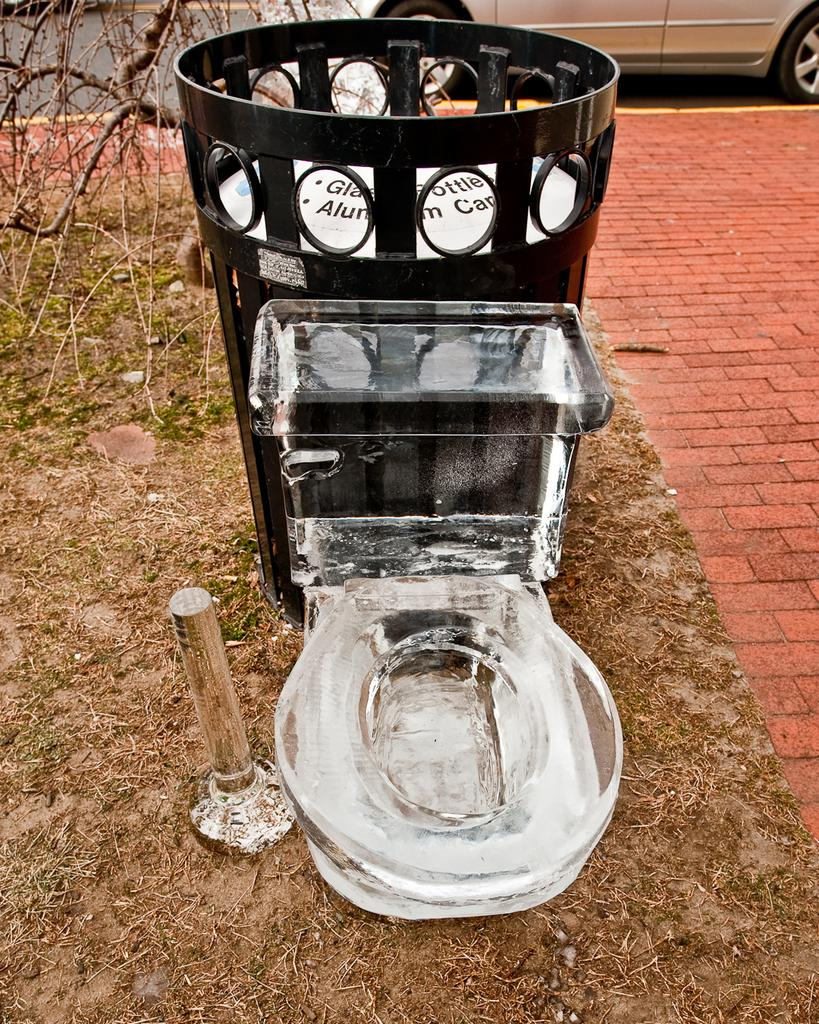<image>
Describe the image concisely. a clear toilet with a white item that says aluminum cans on it 